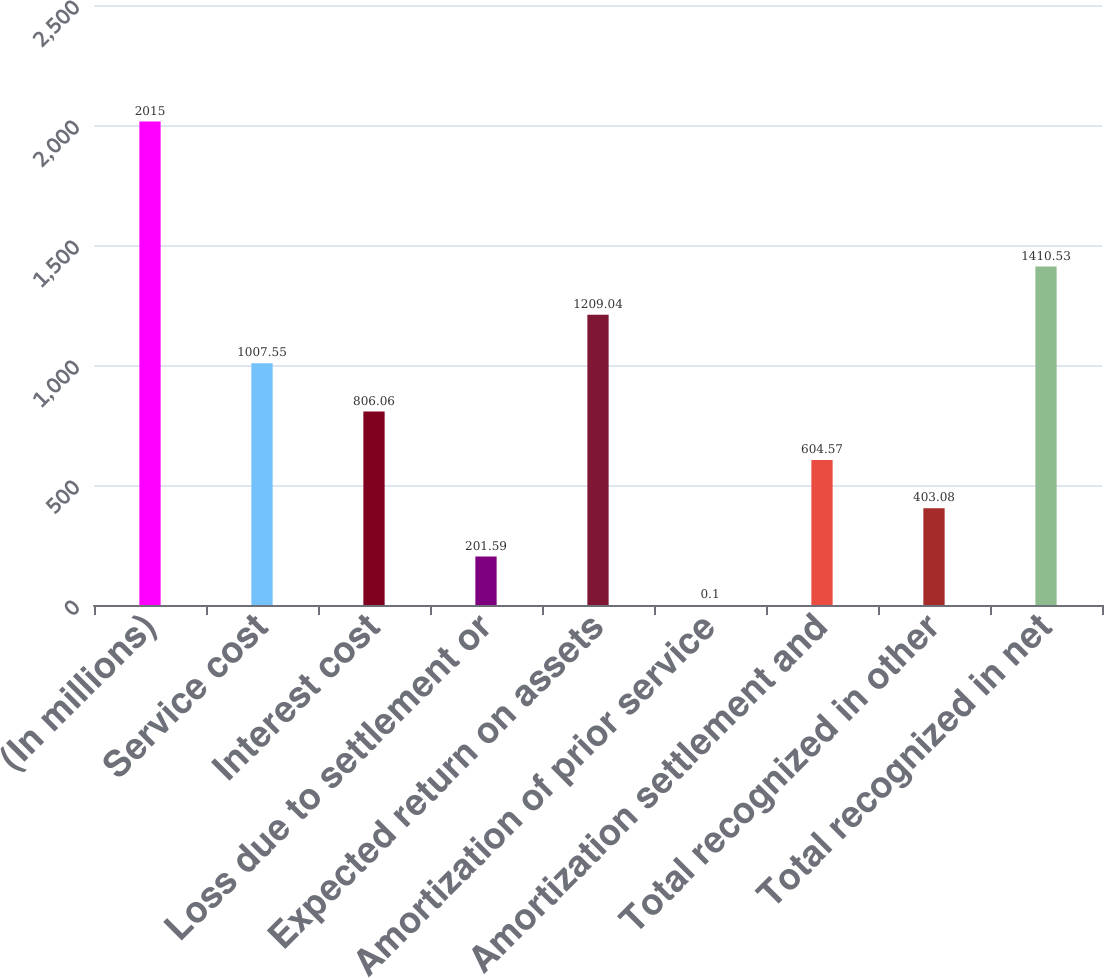Convert chart. <chart><loc_0><loc_0><loc_500><loc_500><bar_chart><fcel>(In millions)<fcel>Service cost<fcel>Interest cost<fcel>Loss due to settlement or<fcel>Expected return on assets<fcel>Amortization of prior service<fcel>Amortization settlement and<fcel>Total recognized in other<fcel>Total recognized in net<nl><fcel>2015<fcel>1007.55<fcel>806.06<fcel>201.59<fcel>1209.04<fcel>0.1<fcel>604.57<fcel>403.08<fcel>1410.53<nl></chart> 